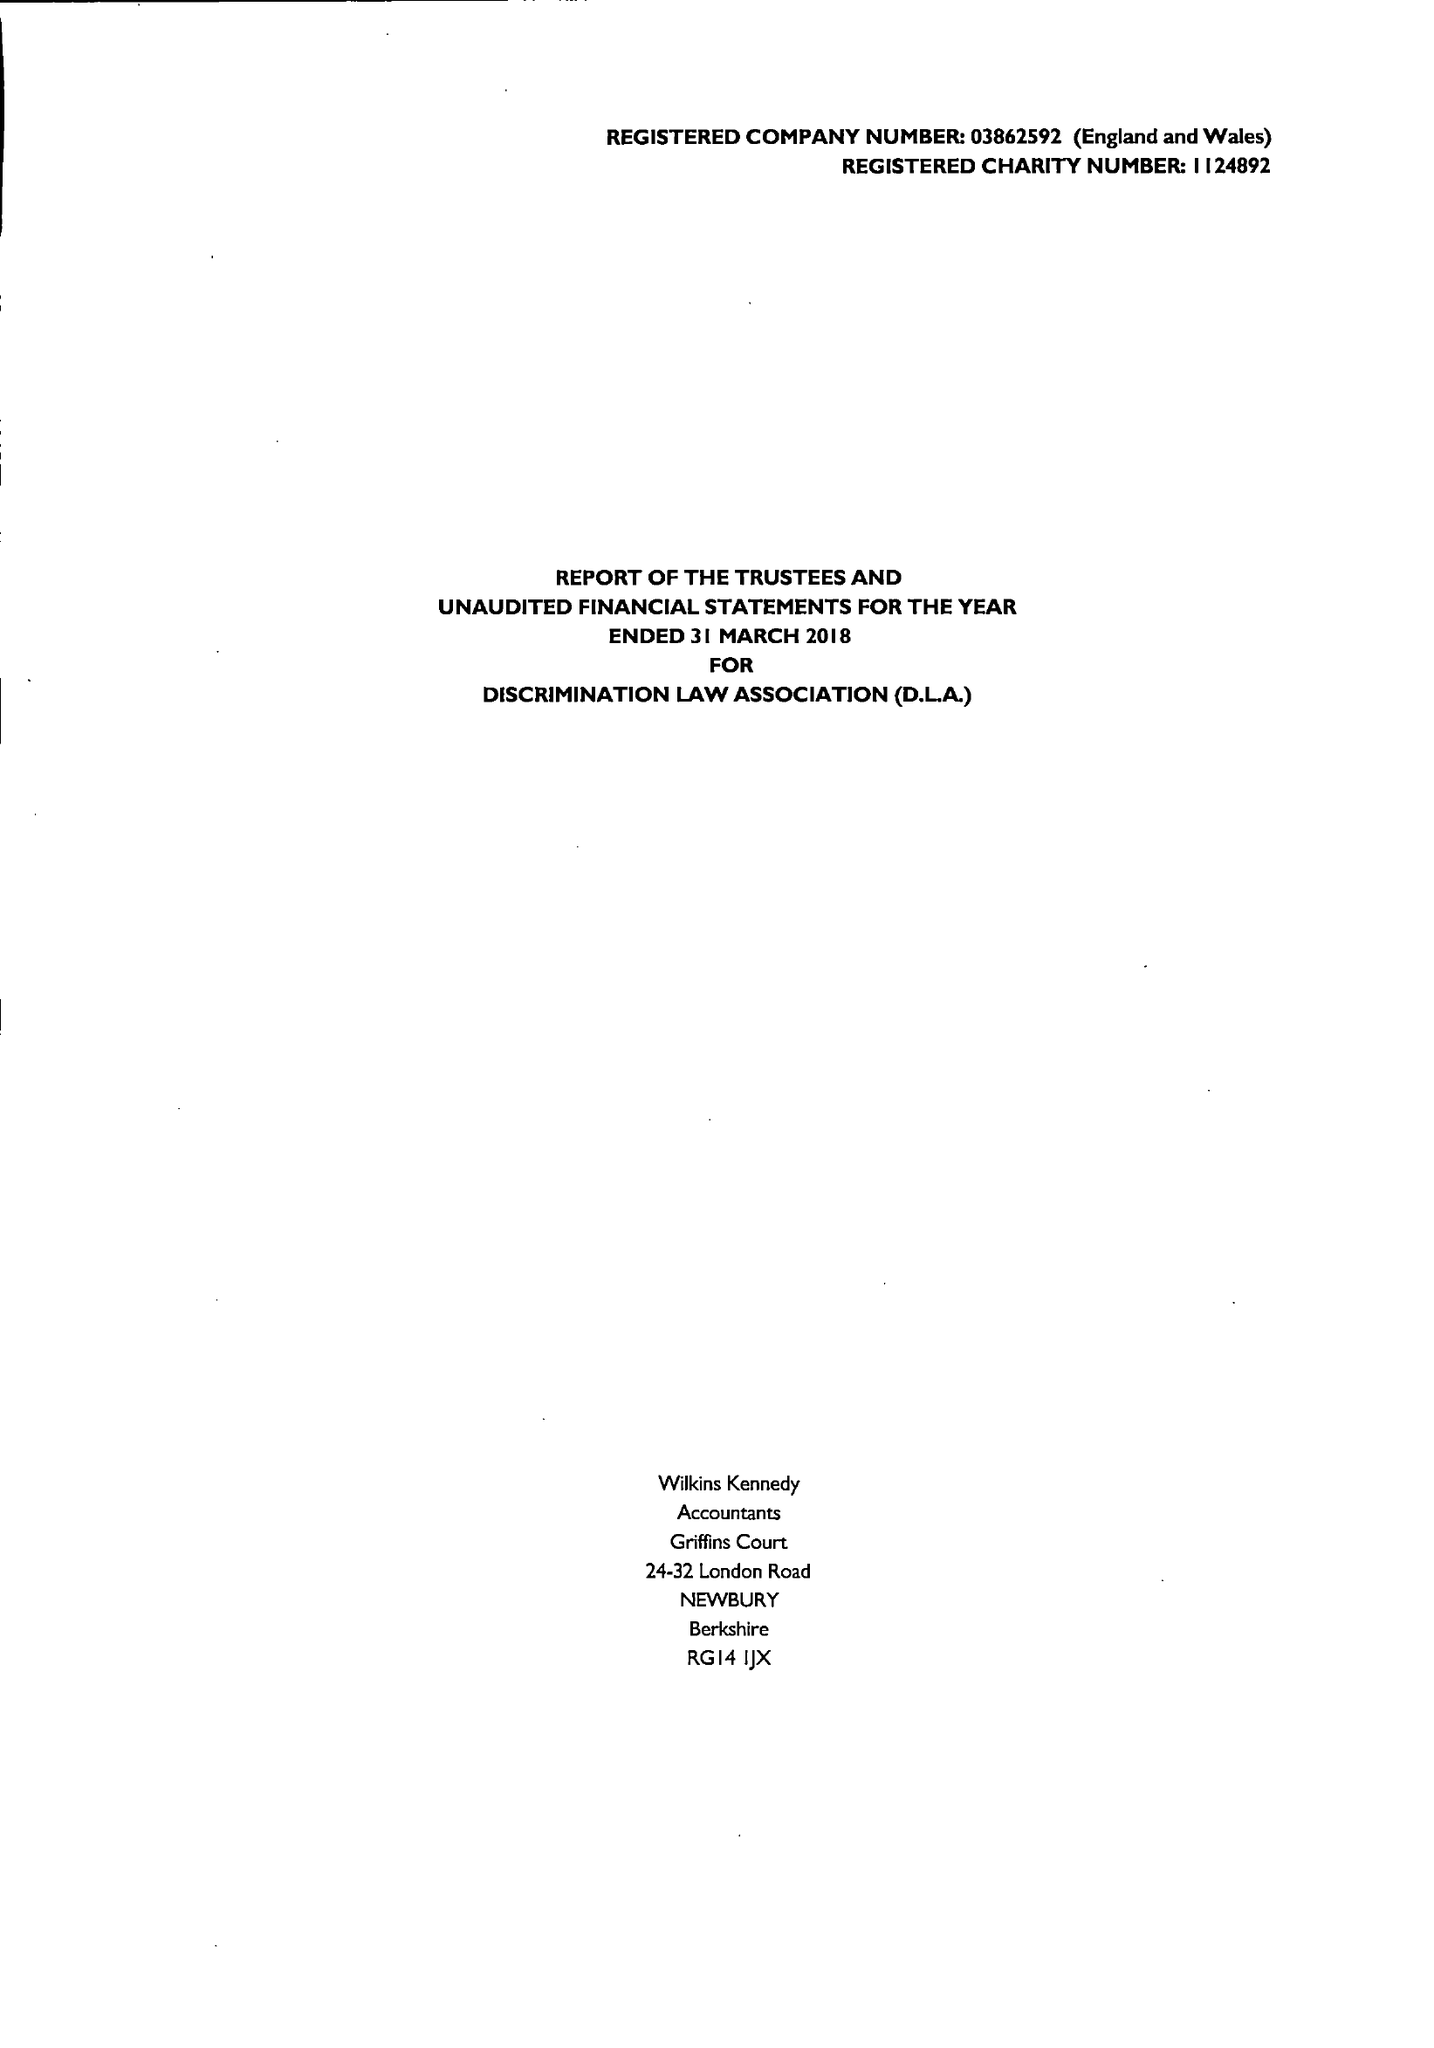What is the value for the address__street_line?
Answer the question using a single word or phrase. 33 CROMWELL AVENUE 